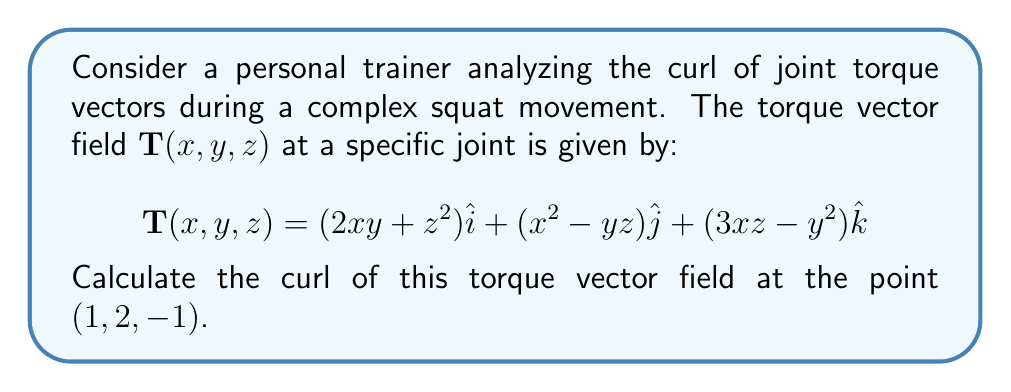Could you help me with this problem? To calculate the curl of the torque vector field, we need to follow these steps:

1) The curl of a vector field $\mathbf{F}(x,y,z) = P\hat{i} + Q\hat{j} + R\hat{k}$ is given by:

   $$\text{curl }\mathbf{F} = \nabla \times \mathbf{F} = \left(\frac{\partial R}{\partial y} - \frac{\partial Q}{\partial z}\right)\hat{i} + \left(\frac{\partial P}{\partial z} - \frac{\partial R}{\partial x}\right)\hat{j} + \left(\frac{\partial Q}{\partial x} - \frac{\partial P}{\partial y}\right)\hat{k}$$

2) In our case, 
   $P = 2xy + z^2$
   $Q = x^2 - yz$
   $R = 3xz - y^2$

3) Let's calculate each partial derivative:

   $\frac{\partial R}{\partial y} = -2y$
   $\frac{\partial Q}{\partial z} = -y$
   $\frac{\partial P}{\partial z} = 2z$
   $\frac{\partial R}{\partial x} = 3z$
   $\frac{\partial Q}{\partial x} = 2x$
   $\frac{\partial P}{\partial y} = 2x$

4) Now, let's substitute these into the curl formula:

   $$\text{curl }\mathbf{T} = (-2y+y)\hat{i} + (2z-3z)\hat{j} + (2x-2x)\hat{k}$$
   
   $$= (-y)\hat{i} + (-z)\hat{j} + (0)\hat{k}$$

5) Finally, we need to evaluate this at the point $(1, 2, -1)$:

   $$\text{curl }\mathbf{T}(1,2,-1) = (-2)\hat{i} + (1)\hat{j} + (0)\hat{k}$$

This result represents the rotation of the torque vector field at the given point during the complex squat movement.
Answer: $-2\hat{i} + \hat{j}$ 